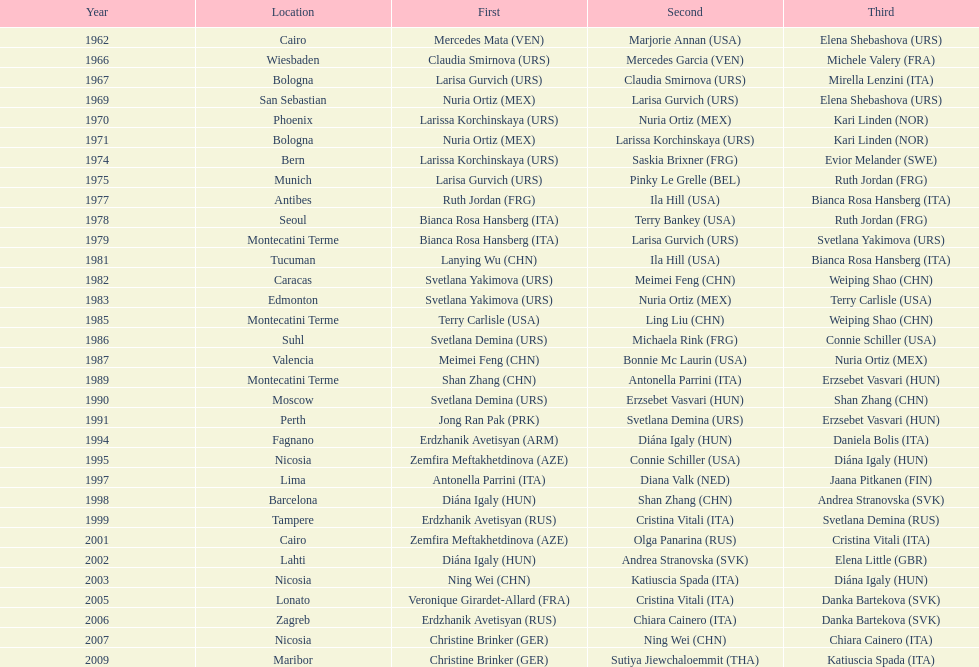What is the total of silver for cairo 0. 